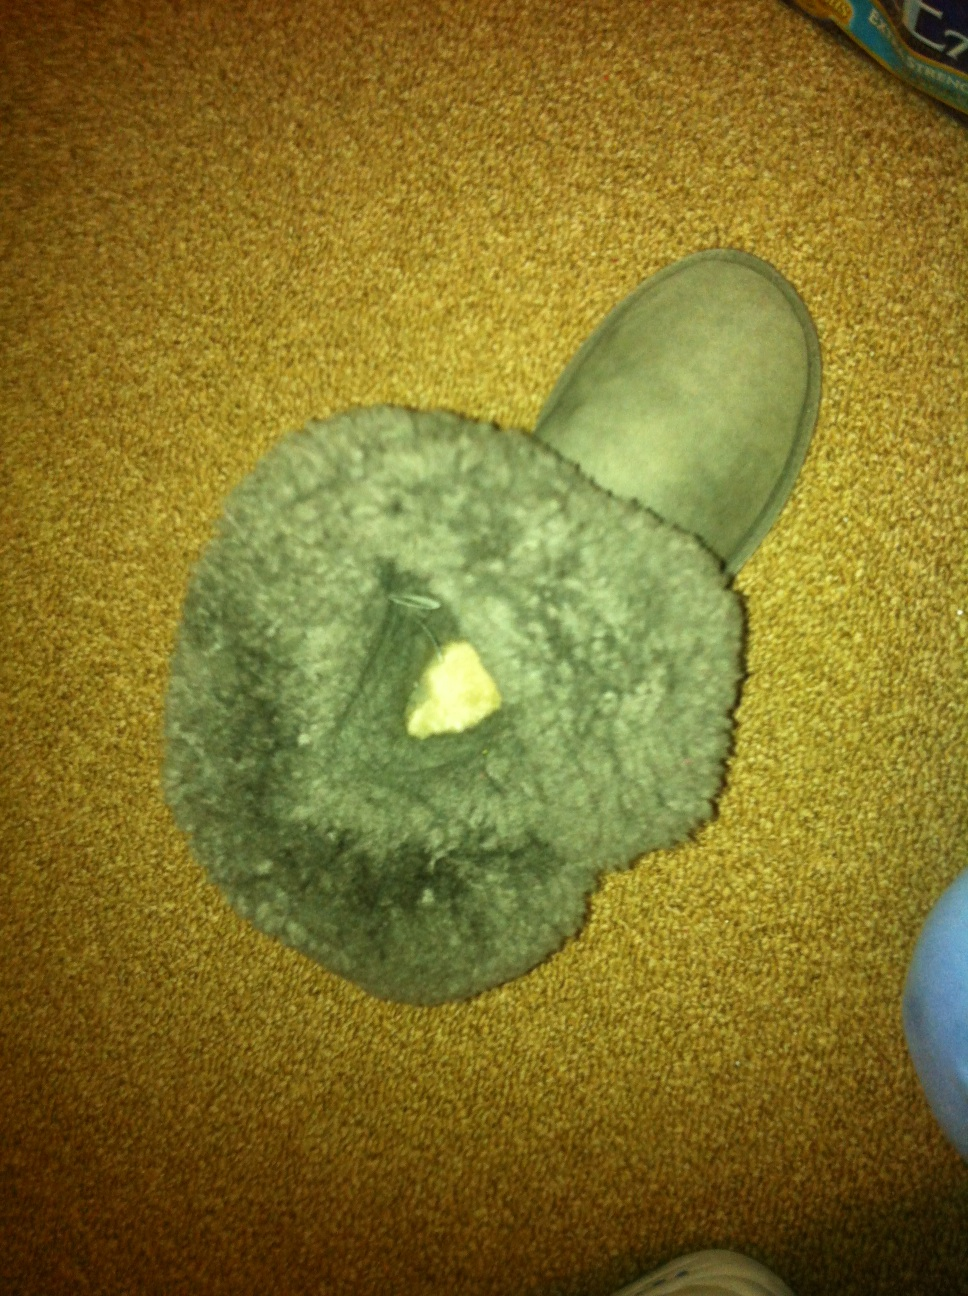What do you think about the overall condition of this boot? The boot appears to be in decent condition. While it shows signs of light wear, such as a slightly darkened inner lining, it doesn’t seem to have any major damage or tears. Regular cleaning and maintenance should help keep it in good shape. Do you think it's worth repairing if it has any hidden damages? If the boot has hidden damages, such as worn stitching or inner lining issues, it might be worth assessing the cost of repair versus the value and lifespan of the boot. If the boot is of high quality and provides good comfort, investing in repairs could be a worthwhile decision to extend its usability. Do you have any tips for enhancing the longevity of these types of boots? To enhance the longevity of these types of boots, here are some tips you can follow:
1. Regular Cleaning: Routinely clean your boots with appropriate cleaning methods suitable for the material. Use a soft brush to remove dirt and debris.
2. Waterproofing: Apply a waterproofing spray to protect against moisture and stains, especially if you plan on wearing them in wet conditions.
3. Proper Storage: Store your boots in a cool, dry place. Use boot shapers to retain their shape and avoid placing them in direct sunlight.
4. Rotational Use: Avoid wearing the sharegpt4v/same boots every day. Give them time to air out and breathe between uses.
5. Condition the Leather: If the boots have leather elements, use a leather conditioner periodically to keep the material supple and prevent cracking.
6. Address Issues Promptly: Fix any minor damages, like loose stitching or worn soles, as soon as you notice them to prevent worsening conditions. 